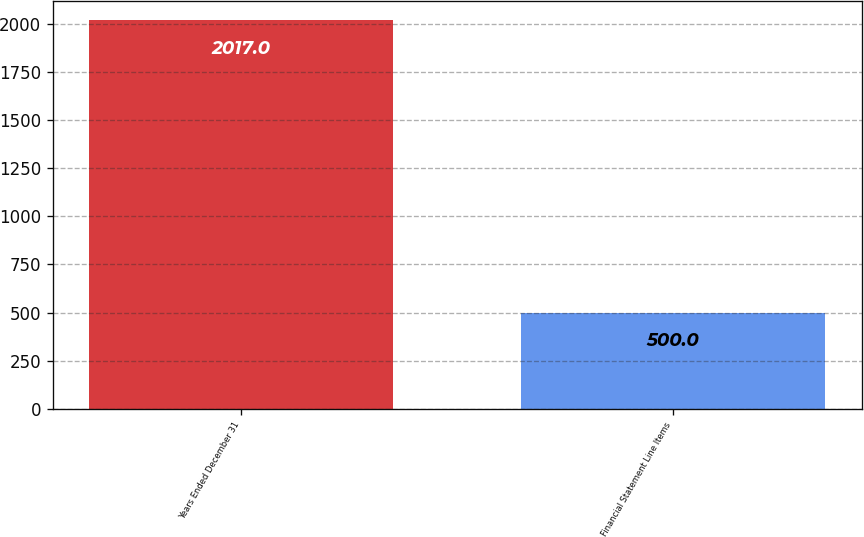<chart> <loc_0><loc_0><loc_500><loc_500><bar_chart><fcel>Years Ended December 31<fcel>Financial Statement Line Items<nl><fcel>2017<fcel>500<nl></chart> 